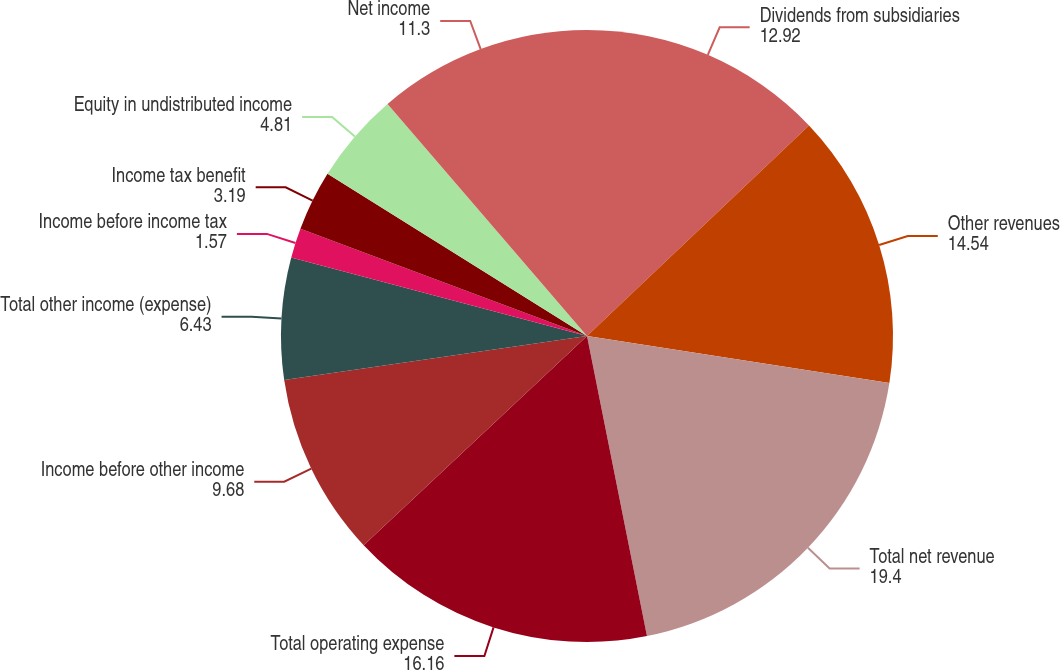Convert chart. <chart><loc_0><loc_0><loc_500><loc_500><pie_chart><fcel>Dividends from subsidiaries<fcel>Other revenues<fcel>Total net revenue<fcel>Total operating expense<fcel>Income before other income<fcel>Total other income (expense)<fcel>Income before income tax<fcel>Income tax benefit<fcel>Equity in undistributed income<fcel>Net income<nl><fcel>12.92%<fcel>14.54%<fcel>19.4%<fcel>16.16%<fcel>9.68%<fcel>6.43%<fcel>1.57%<fcel>3.19%<fcel>4.81%<fcel>11.3%<nl></chart> 